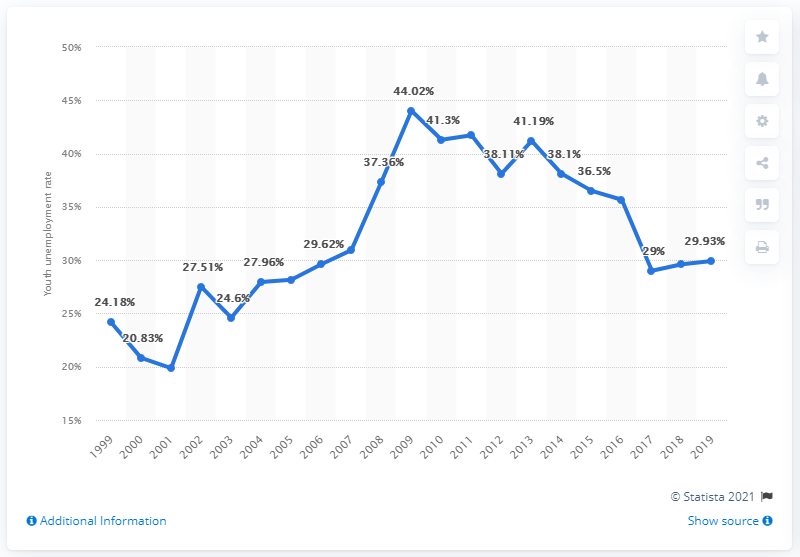Highlight a few significant elements in this photo. In 2019, the youth unemployment rate in Georgia was 29.93%. 